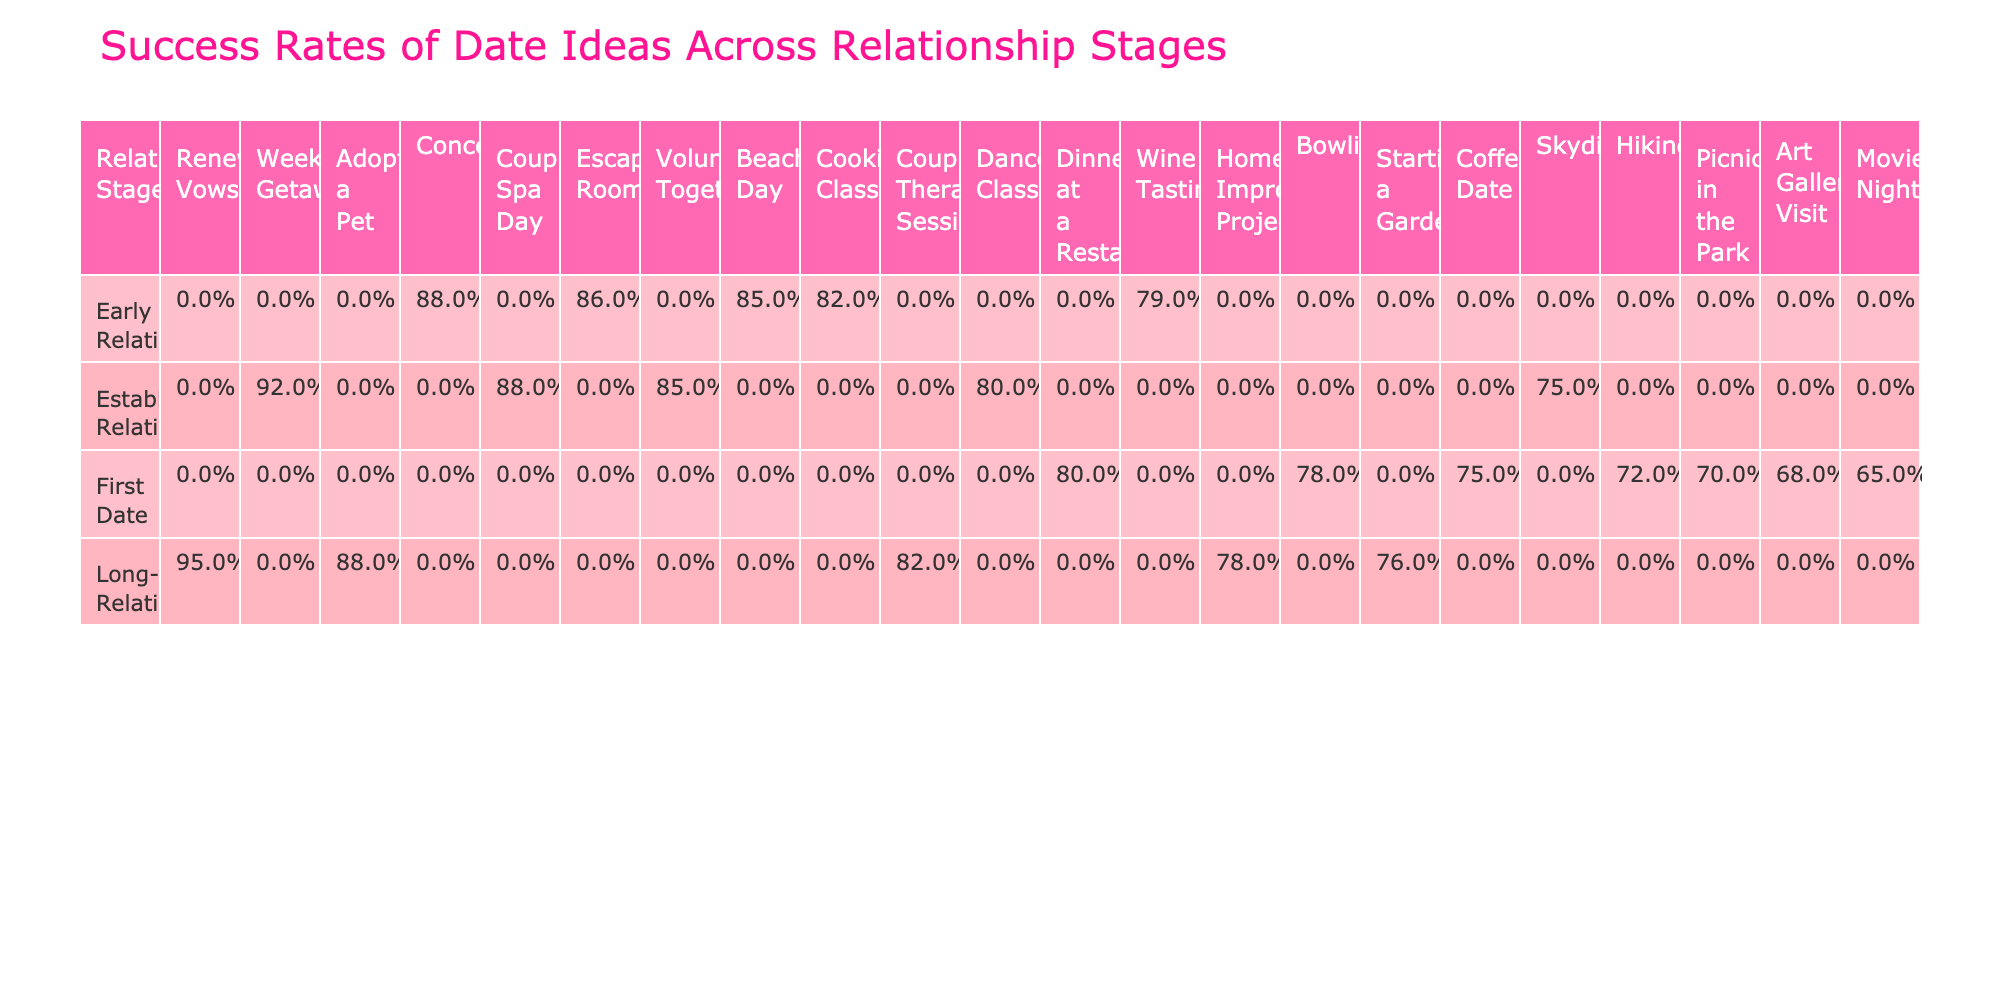What is the success rate of a Bowling date for a First Date? From the 'First Date' row for 'Bowling', the success rate is listed as 78%.
Answer: 78% Which date idea has the highest success rate during the Established Relationship stage? Examining the 'Established Relationship' stage, we find that 'Weekend Getaway' has the highest success rate of 92%.
Answer: 92% Is the success rate of Cooking Class higher than that of Art Gallery Visit in the Early Relationship stage? The success rate for 'Cooking Class' is 82%, while 'Art Gallery Visit' has 68%. Therefore, 82% is greater than 68%.
Answer: Yes What is the difference in success rates between Beach Day and Wine Tasting in the Early Relationship stage? 'Beach Day' has a success rate of 85%, and 'Wine Tasting' has 79%. The difference is 85% - 79% = 6%.
Answer: 6% What is the average success rate of all date ideas in the Long-term Relationship stage? The success rates in the Long-term Relationship stage are 78%, 82%, 95%, and 76%, which sum to 331%. Dividing by 4 gives an average of 82.75%.
Answer: 82.75% 